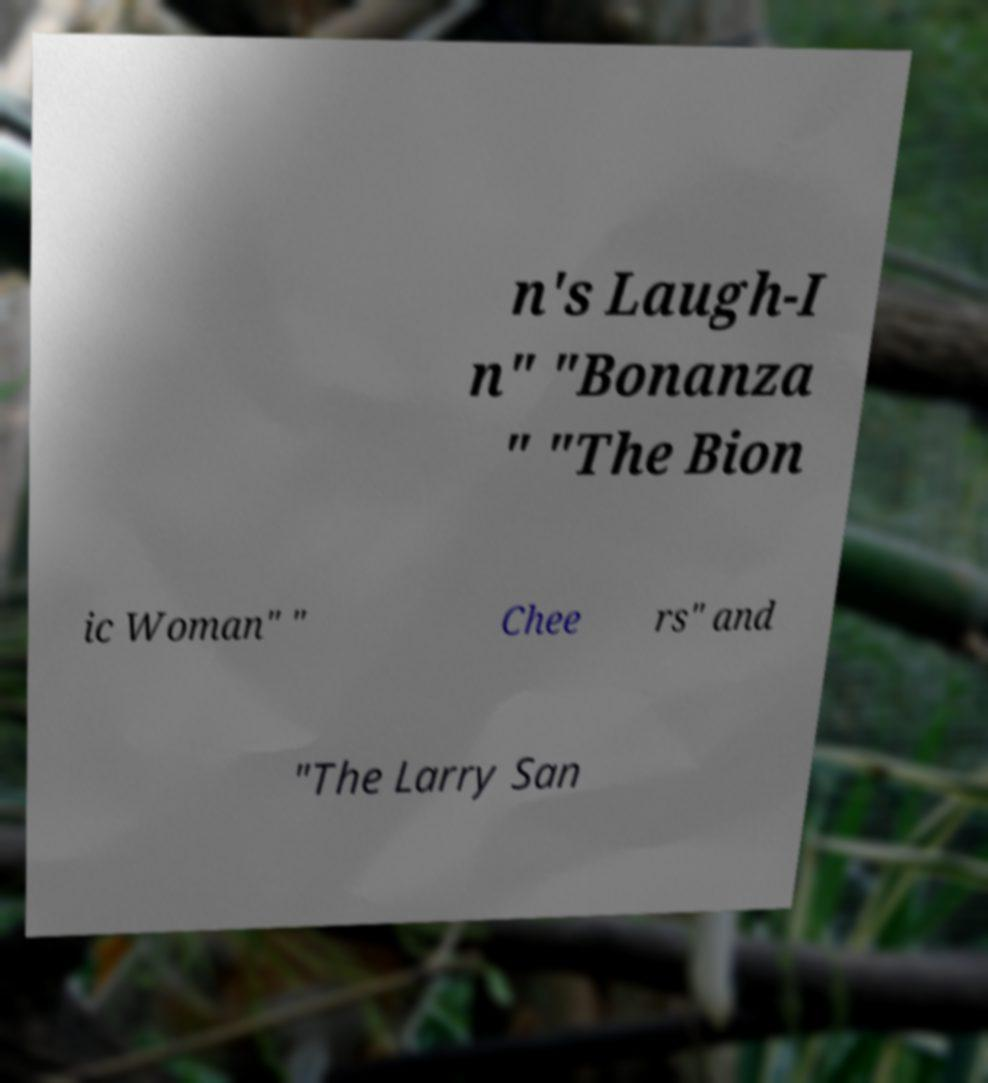Please read and relay the text visible in this image. What does it say? n's Laugh-I n" "Bonanza " "The Bion ic Woman" " Chee rs" and "The Larry San 